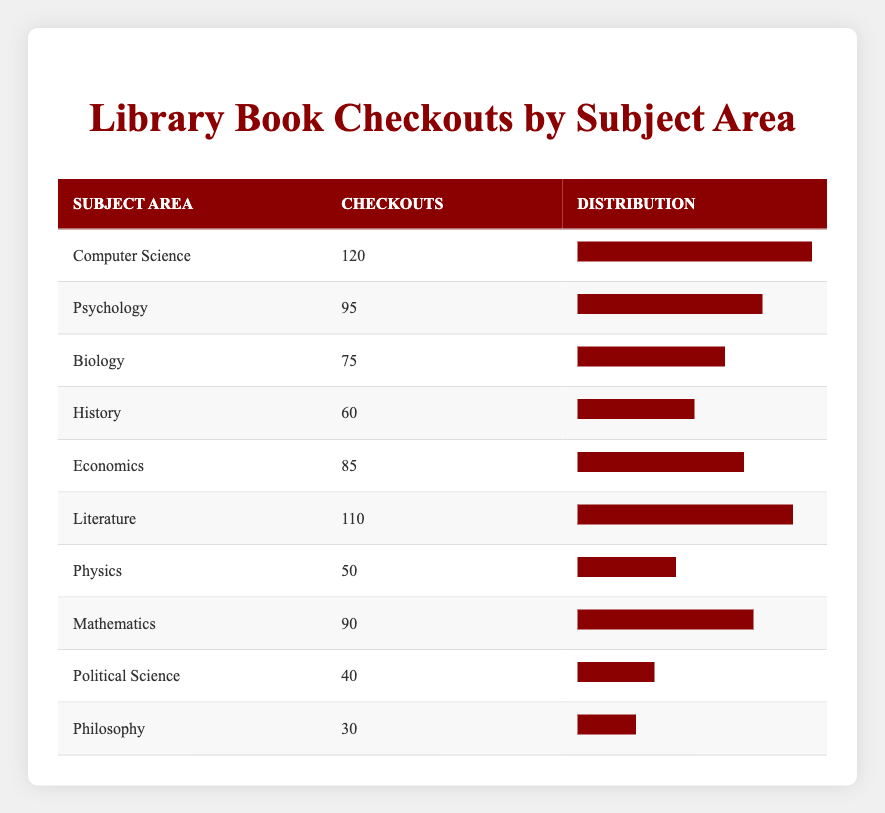What is the subject area with the highest number of book checkouts? By examining the table, it's clear that the subject area "Computer Science" has the highest checkouts at 120.
Answer: Computer Science How many checkouts were recorded for Philosophy? The table shows that the subject area "Philosophy" had 30 book checkouts.
Answer: 30 What is the total number of checkouts across all subject areas? Adding the checkouts of all subject areas: 120 + 95 + 75 + 60 + 85 + 110 + 50 + 90 + 40 + 30 = 855.
Answer: 855 Is the number of checkouts for Psychology greater than that for Mathematics? Checking the table, Psychology has 95 checkouts and Mathematics has 90 checkouts, therefore 95 > 90 is true.
Answer: Yes What is the average number of book checkouts per subject area? There are 10 subject areas with a total of 855 checkouts. The average is calculated as 855 divided by 10, which equals 85.5.
Answer: 85.5 Which subject areas had more than 80 checkouts? Reviewing the table, the subject areas with more than 80 checkouts are Computer Science (120), Literature (110), Economics (85), and Psychology (95).
Answer: Computer Science, Literature, Economics, Psychology What is the difference in checkouts between Biology and History? Biology has 75 checkouts and History has 60. Calculating the difference: 75 - 60 = 15.
Answer: 15 Are there more checkouts in the subject area of Literature than in Physics? Literature has 110 checkouts, while Physics has 50. Since 110 > 50, the statement is true.
Answer: Yes What is the median number of checkouts among the subject areas? To find the median, we first list the number of checkouts in order: 30, 40, 50, 60, 75, 85, 90, 95, 110, 120. The two middle values are 75 and 85; thus, the median is (75 + 85) / 2 = 80.
Answer: 80 